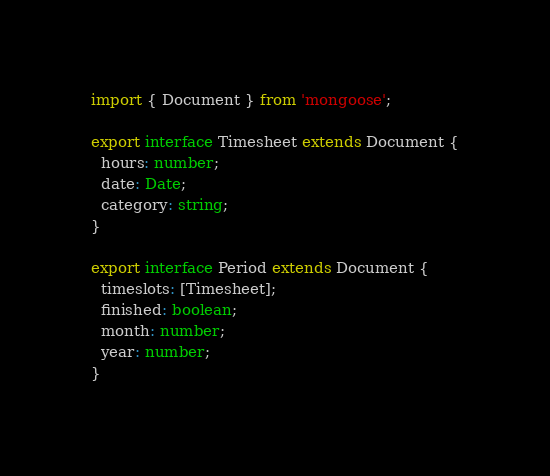Convert code to text. <code><loc_0><loc_0><loc_500><loc_500><_TypeScript_>import { Document } from 'mongoose';

export interface Timesheet extends Document {
  hours: number;
  date: Date;
  category: string;
}

export interface Period extends Document {
  timeslots: [Timesheet];
  finished: boolean;
  month: number;
  year: number;
}
</code> 